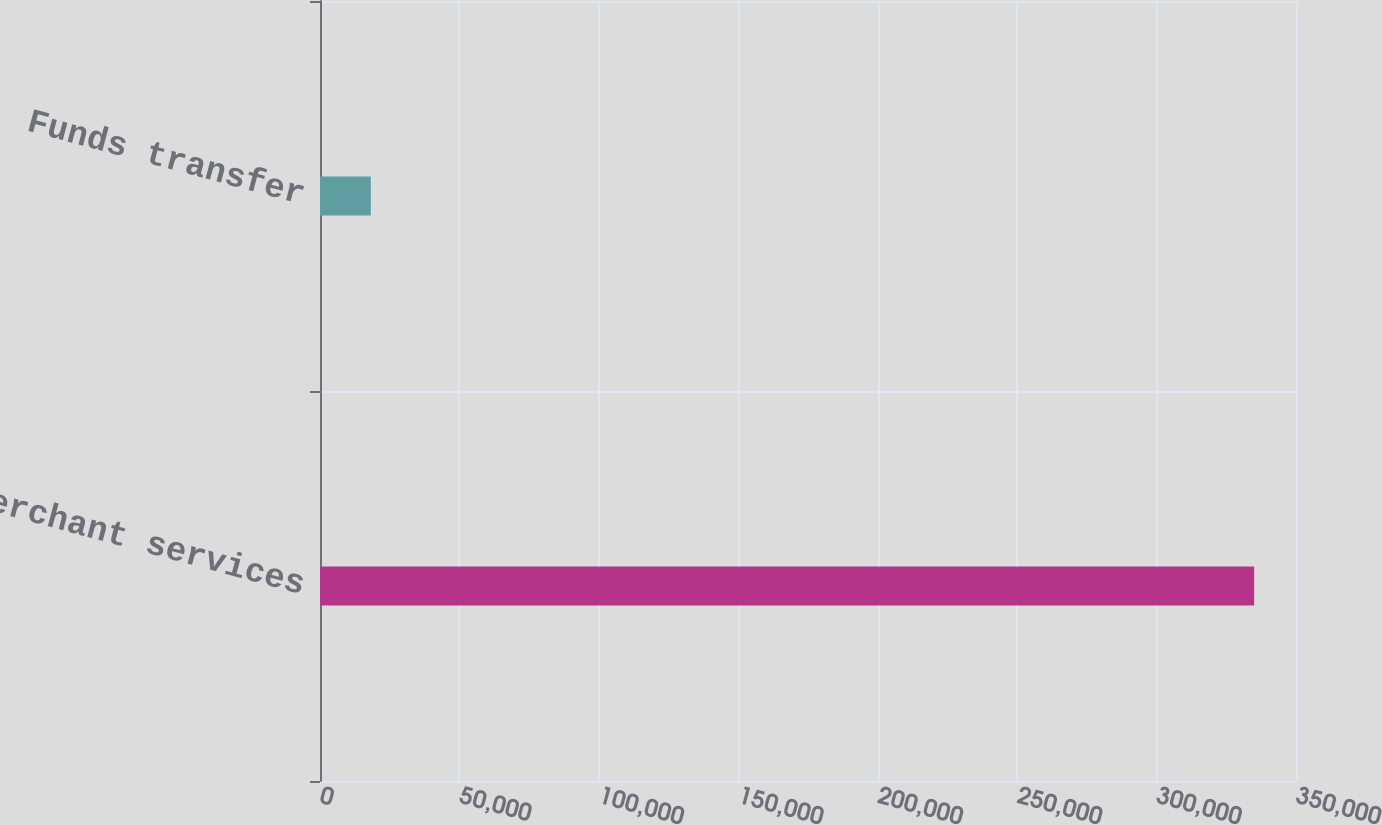<chart> <loc_0><loc_0><loc_500><loc_500><bar_chart><fcel>Merchant services<fcel>Funds transfer<nl><fcel>334979<fcel>18216<nl></chart> 